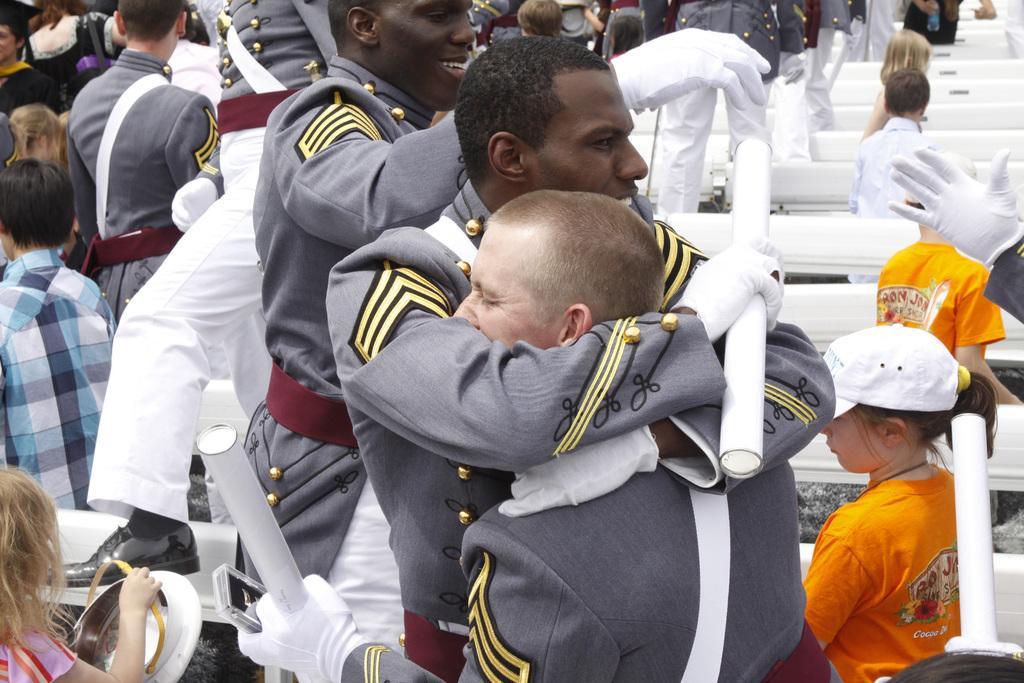Could you give a brief overview of what you see in this image? In this image two persons wearing uniforms are hugging each other. They are holding sticks in their hand. Behind them there are few persons. Right side there are few benches. In between benches there are few kids standing. A girl wearing orange shirt is having cap. Left bottom there is a girl holding a cap. A person is standing on the bench. He is wearing uniform and shoes. 